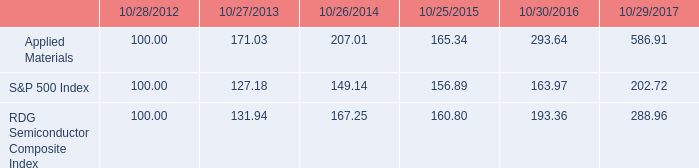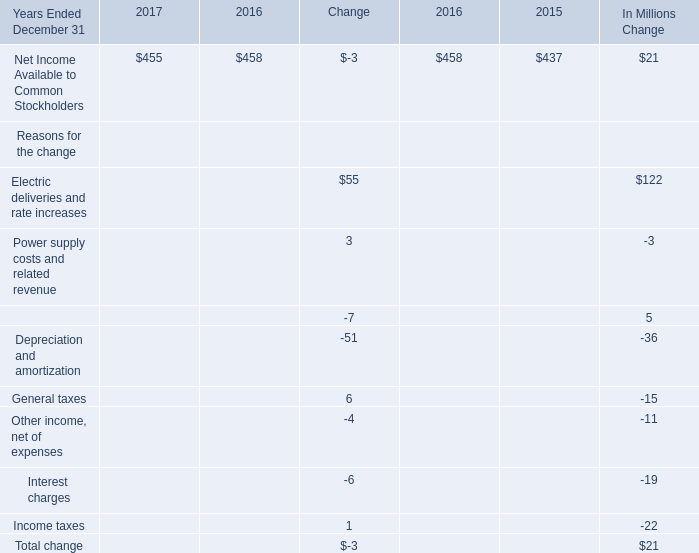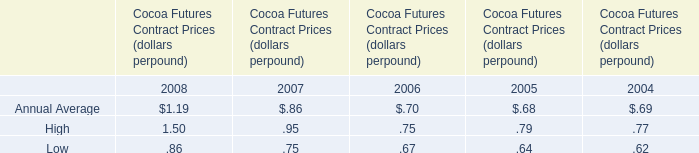If Net Income Available to Common Stockholders develops with the same growth rate in 2017, what will it reach in 2018? (in million) 
Computations: (455 * (1 + (-3 / 458)))
Answer: 452.01965. 